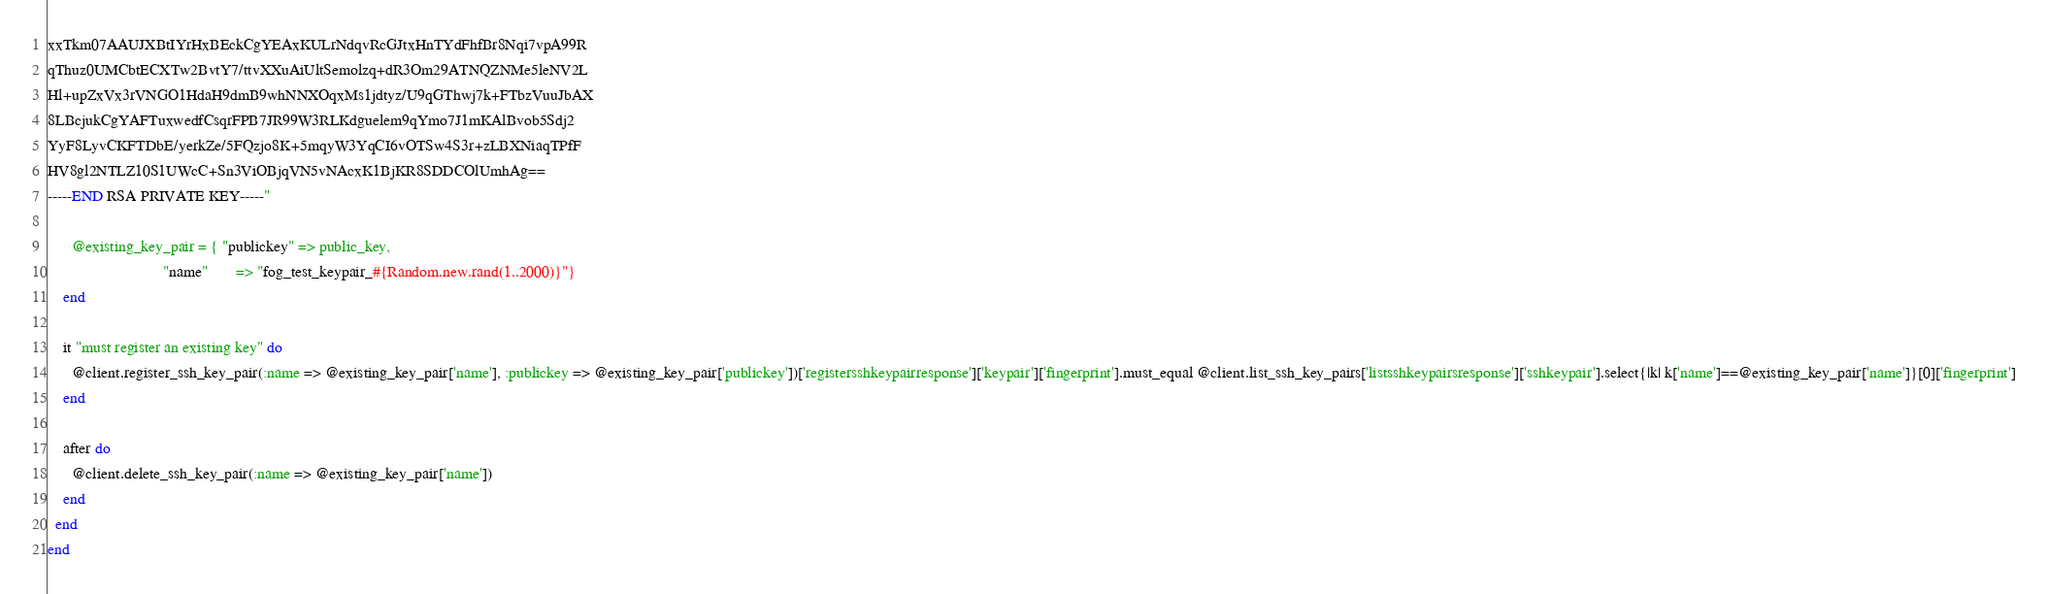Convert code to text. <code><loc_0><loc_0><loc_500><loc_500><_Ruby_>xxTkm07AAUJXBtIYrHxBEckCgYEAxKULrNdqvRcGJtxHnTYdFhfBr8Nqi7vpA99R
qThuz0UMCbtECXTw2BvtY7/ttvXXuAiUltSemolzq+dR3Om29ATNQZNMe5leNV2L
Hl+upZxVx3rVNGO1HdaH9dmB9whNNXOqxMs1jdtyz/U9qGThwj7k+FTbzVuuJbAX
8LBcjukCgYAFTuxwedfCsqrFPB7JR99W3RLKdguelem9qYmo7J1mKAlBvob5Sdj2
YyF8LyvCKFTDbE/yerkZe/5FQzjo8K+5mqyW3YqCI6vOTSw4S3r+zLBXNiaqTPfF
HV8gl2NTLZ10S1UWcC+Sn3ViOBjqVN5vNAcxK1BjKR8SDDCOlUmhAg==
-----END RSA PRIVATE KEY-----"
      
      @existing_key_pair = { "publickey" => public_key,
                             "name"       => "fog_test_keypair_#{Random.new.rand(1..2000)}"}
    end
    
    it "must register an existing key" do
      @client.register_ssh_key_pair(:name => @existing_key_pair['name'], :publickey => @existing_key_pair['publickey'])['registersshkeypairresponse']['keypair']['fingerprint'].must_equal @client.list_ssh_key_pairs['listsshkeypairsresponse']['sshkeypair'].select{|k| k['name']==@existing_key_pair['name']}[0]['fingerprint']
    end
    
    after do
      @client.delete_ssh_key_pair(:name => @existing_key_pair['name'])
    end
  end
end
</code> 